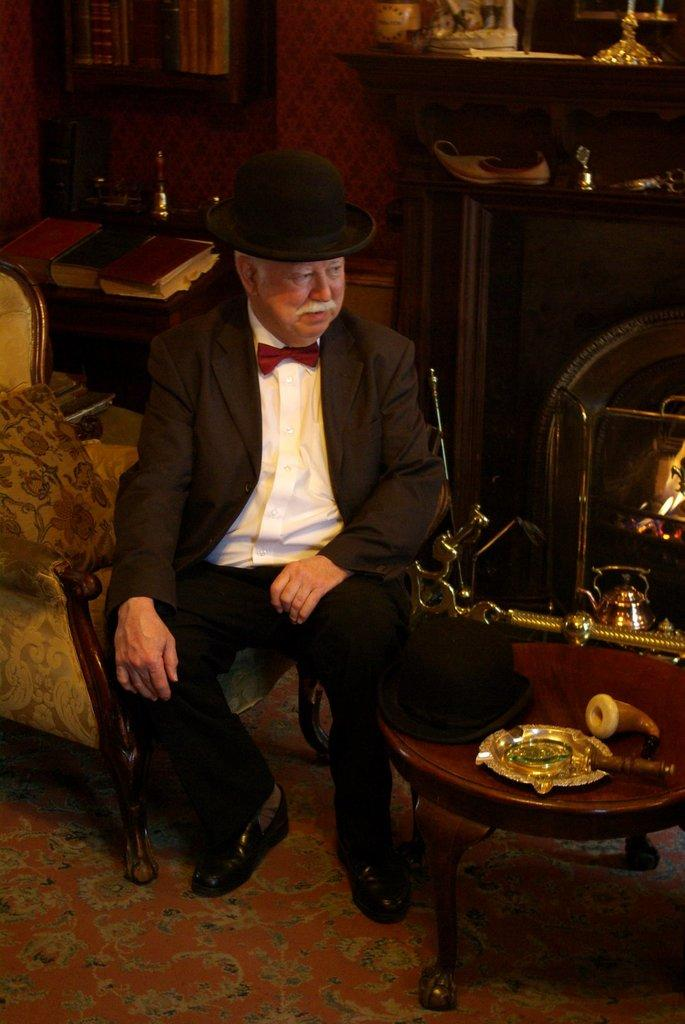Who is present in the image? There is a man in the image. What is the man doing in the image? The man is seated on a chair in the image. What is the man wearing on his head? The man is wearing a hat in the image. What color is the man's suit? The man is wearing a black suit in the image. What type of shoes is the man wearing? The man is wearing black shoes in the image. What type of bread is the man holding in the image? There is no bread present in the image; the man is wearing a hat and a black suit while seated on a chair. 